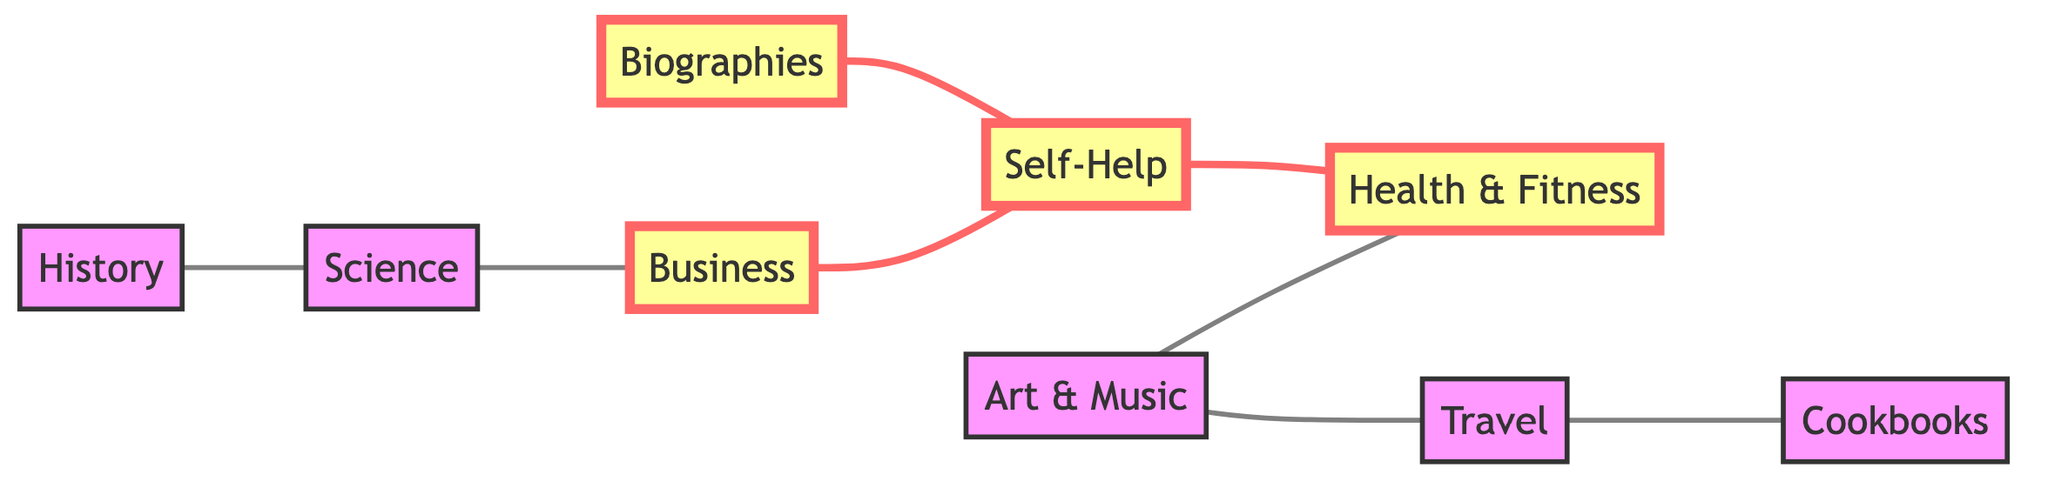What's the total number of categories represented in the graph? The graph shows eight nodes, each representing a different non-fiction category: Biographies, Self-Help, History, Science, Business, Travel, Cookbooks, and Art & Music. Hence, you count the nodes to find the total.
Answer: 8 Which categories are directly connected to Self-Help? Self-Help has two direct connections: Biographies and Health & Fitness. By inspecting the edges connected to the Self-Help node, you can identify these two categories as neighbors.
Answer: Biographies, Health & Fitness How many edges are present in the graph? To find the total edges, you can count each line (or connection) that connects the nodes. The graph has seven connections between the different categories, which represent the edges.
Answer: 7 Which category connects both Travel and Art & Music? By examining the edges, you can see that Travel has a direct line connecting to Art & Music. Thus, the answer is the Travel category, as it creates a direct connection between these two.
Answer: Travel How many categories are highlighted in the diagram? The highlighted categories are Biographies, Self-Help, Business, and Health & Fitness. By identifying which nodes have a different color or style, you can conclude that there are four highlighted categories.
Answer: 4 What is the relationship between Science and Business? Science is connected to Business through a direct edge in the graph, which visually indicates a relationship of adjacency between these two categories. You identify this by looking for a direct line connecting the two nodes.
Answer: Direct connection 